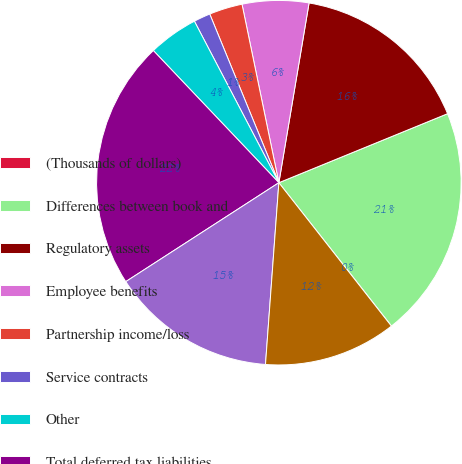Convert chart. <chart><loc_0><loc_0><loc_500><loc_500><pie_chart><fcel>(Thousands of dollars)<fcel>Differences between book and<fcel>Regulatory assets<fcel>Employee benefits<fcel>Partnership income/loss<fcel>Service contracts<fcel>Other<fcel>Total deferred tax liabilities<fcel>Net operating loss carry<fcel>Other comprehensive income<nl><fcel>0.01%<fcel>20.58%<fcel>16.17%<fcel>5.89%<fcel>2.95%<fcel>1.48%<fcel>4.42%<fcel>22.04%<fcel>14.7%<fcel>11.76%<nl></chart> 